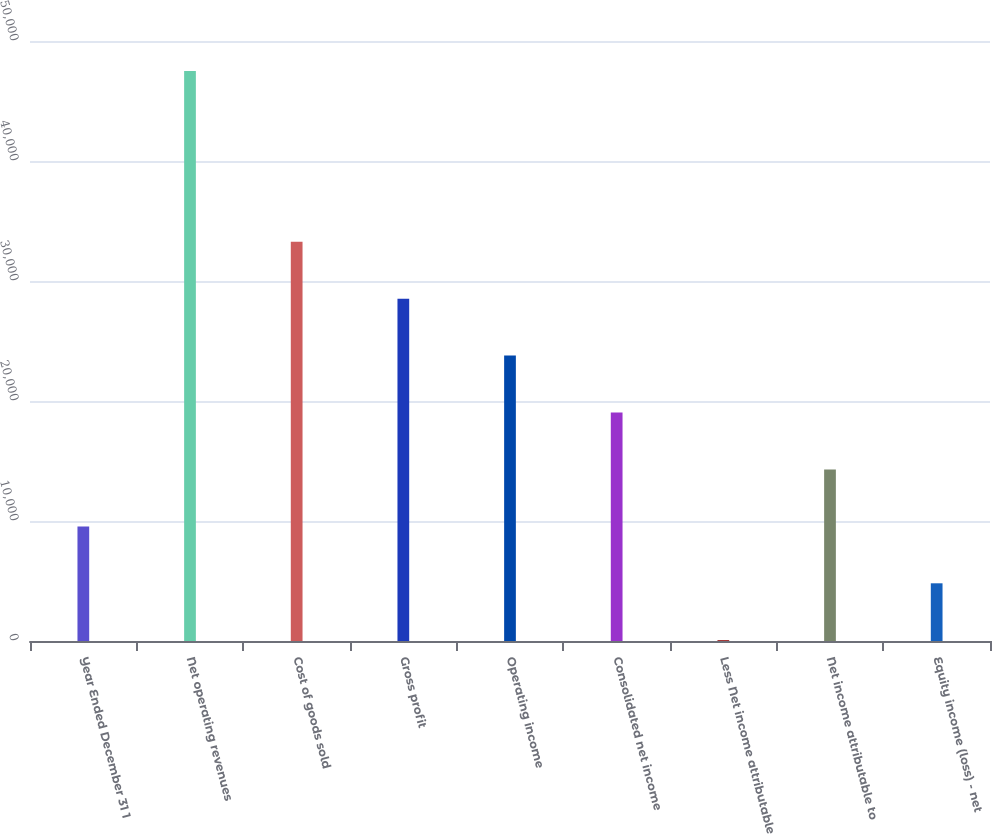Convert chart to OTSL. <chart><loc_0><loc_0><loc_500><loc_500><bar_chart><fcel>Year Ended December 31 1<fcel>Net operating revenues<fcel>Cost of goods sold<fcel>Gross profit<fcel>Operating income<fcel>Consolidated net income<fcel>Less Net income attributable<fcel>Net income attributable to<fcel>Equity income (loss) - net<nl><fcel>9551.6<fcel>47498<fcel>33268.1<fcel>28524.8<fcel>23781.5<fcel>19038.2<fcel>65<fcel>14294.9<fcel>4808.3<nl></chart> 